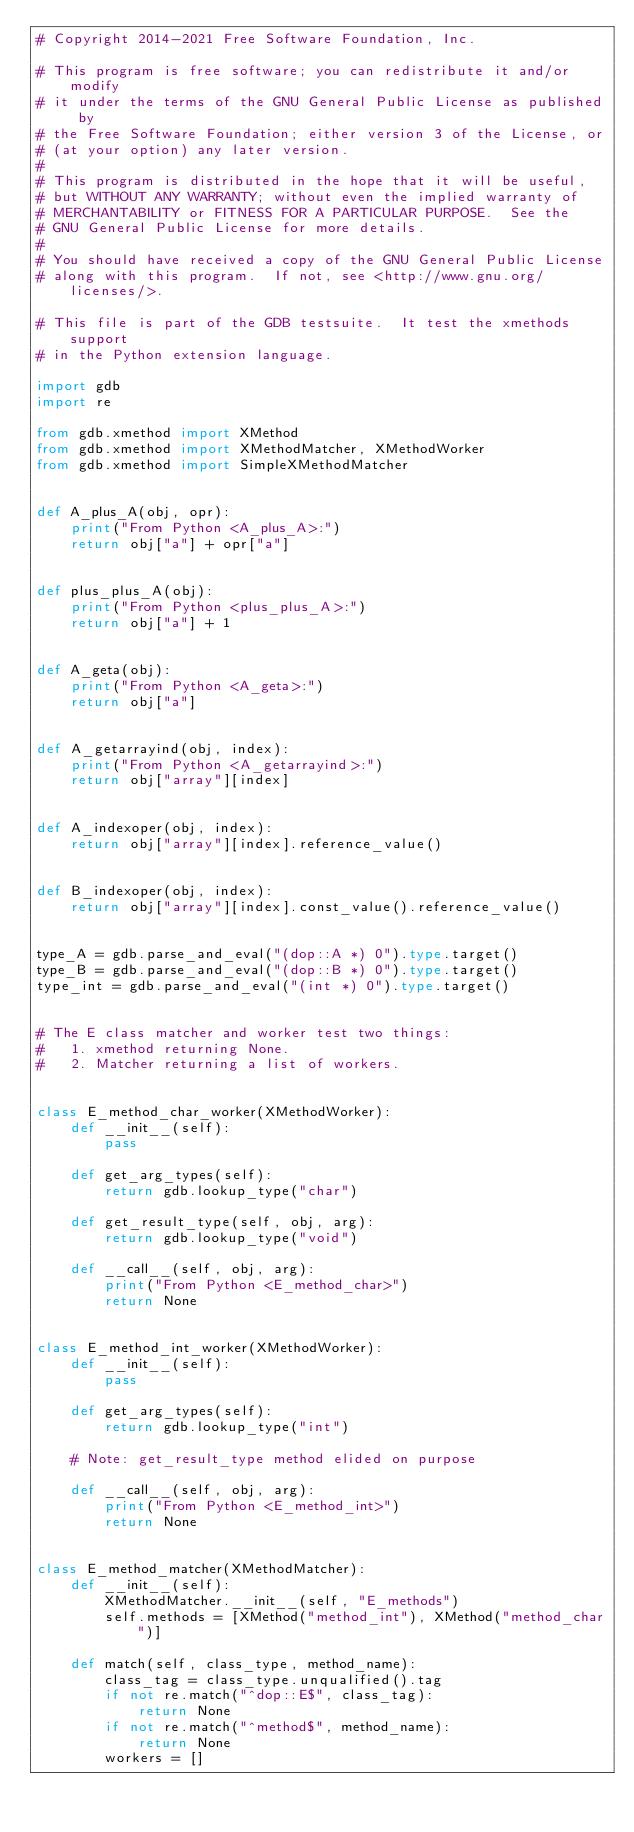Convert code to text. <code><loc_0><loc_0><loc_500><loc_500><_Python_># Copyright 2014-2021 Free Software Foundation, Inc.

# This program is free software; you can redistribute it and/or modify
# it under the terms of the GNU General Public License as published by
# the Free Software Foundation; either version 3 of the License, or
# (at your option) any later version.
#
# This program is distributed in the hope that it will be useful,
# but WITHOUT ANY WARRANTY; without even the implied warranty of
# MERCHANTABILITY or FITNESS FOR A PARTICULAR PURPOSE.  See the
# GNU General Public License for more details.
#
# You should have received a copy of the GNU General Public License
# along with this program.  If not, see <http://www.gnu.org/licenses/>.

# This file is part of the GDB testsuite.  It test the xmethods support
# in the Python extension language.

import gdb
import re

from gdb.xmethod import XMethod
from gdb.xmethod import XMethodMatcher, XMethodWorker
from gdb.xmethod import SimpleXMethodMatcher


def A_plus_A(obj, opr):
    print("From Python <A_plus_A>:")
    return obj["a"] + opr["a"]


def plus_plus_A(obj):
    print("From Python <plus_plus_A>:")
    return obj["a"] + 1


def A_geta(obj):
    print("From Python <A_geta>:")
    return obj["a"]


def A_getarrayind(obj, index):
    print("From Python <A_getarrayind>:")
    return obj["array"][index]


def A_indexoper(obj, index):
    return obj["array"][index].reference_value()


def B_indexoper(obj, index):
    return obj["array"][index].const_value().reference_value()


type_A = gdb.parse_and_eval("(dop::A *) 0").type.target()
type_B = gdb.parse_and_eval("(dop::B *) 0").type.target()
type_int = gdb.parse_and_eval("(int *) 0").type.target()


# The E class matcher and worker test two things:
#   1. xmethod returning None.
#   2. Matcher returning a list of workers.


class E_method_char_worker(XMethodWorker):
    def __init__(self):
        pass

    def get_arg_types(self):
        return gdb.lookup_type("char")

    def get_result_type(self, obj, arg):
        return gdb.lookup_type("void")

    def __call__(self, obj, arg):
        print("From Python <E_method_char>")
        return None


class E_method_int_worker(XMethodWorker):
    def __init__(self):
        pass

    def get_arg_types(self):
        return gdb.lookup_type("int")

    # Note: get_result_type method elided on purpose

    def __call__(self, obj, arg):
        print("From Python <E_method_int>")
        return None


class E_method_matcher(XMethodMatcher):
    def __init__(self):
        XMethodMatcher.__init__(self, "E_methods")
        self.methods = [XMethod("method_int"), XMethod("method_char")]

    def match(self, class_type, method_name):
        class_tag = class_type.unqualified().tag
        if not re.match("^dop::E$", class_tag):
            return None
        if not re.match("^method$", method_name):
            return None
        workers = []</code> 